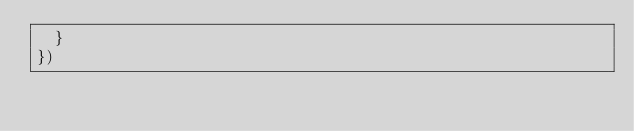Convert code to text. <code><loc_0><loc_0><loc_500><loc_500><_JavaScript_>  }
})





</code> 